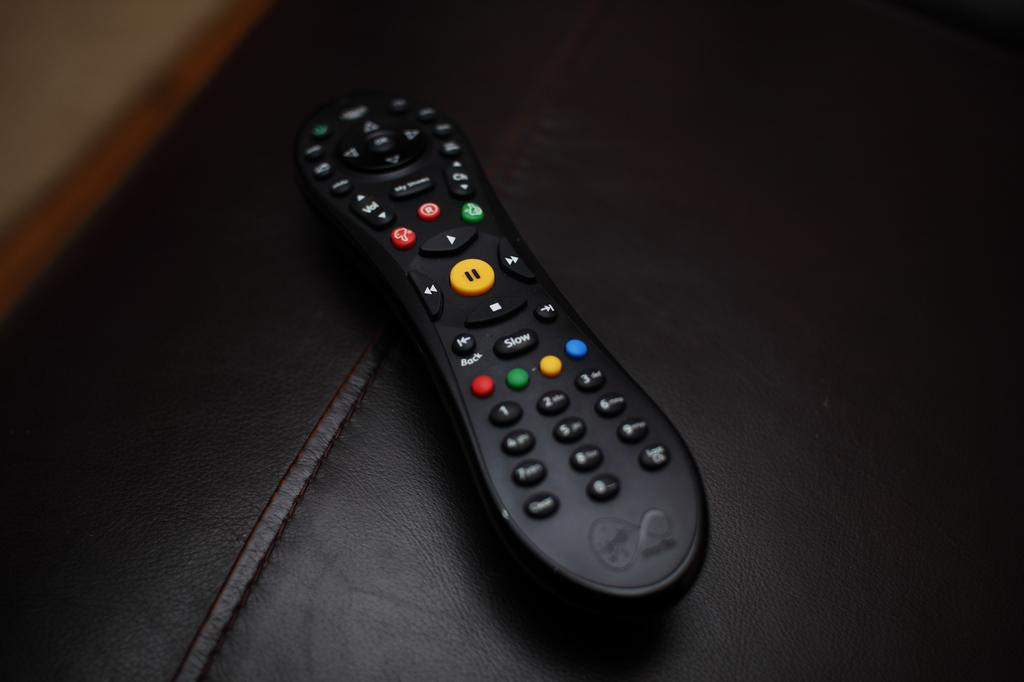What is the large yellow button on the center of this remote?
Keep it short and to the point. Pause. What number is below the red button?
Make the answer very short. 1. 